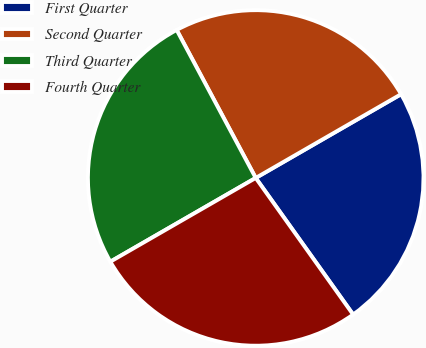Convert chart. <chart><loc_0><loc_0><loc_500><loc_500><pie_chart><fcel>First Quarter<fcel>Second Quarter<fcel>Third Quarter<fcel>Fourth Quarter<nl><fcel>23.46%<fcel>24.49%<fcel>25.51%<fcel>26.54%<nl></chart> 